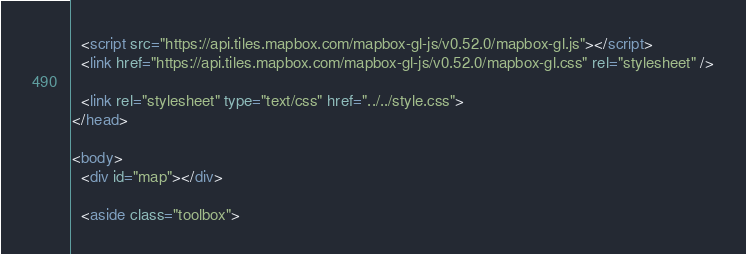<code> <loc_0><loc_0><loc_500><loc_500><_HTML_>
  <script src="https://api.tiles.mapbox.com/mapbox-gl-js/v0.52.0/mapbox-gl.js"></script>
  <link href="https://api.tiles.mapbox.com/mapbox-gl-js/v0.52.0/mapbox-gl.css" rel="stylesheet" />

  <link rel="stylesheet" type="text/css" href="../../style.css">
</head>

<body>
  <div id="map"></div>

  <aside class="toolbox"></code> 